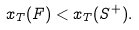<formula> <loc_0><loc_0><loc_500><loc_500>x _ { T } ( F ) < x _ { T } ( S ^ { + } ) .</formula> 